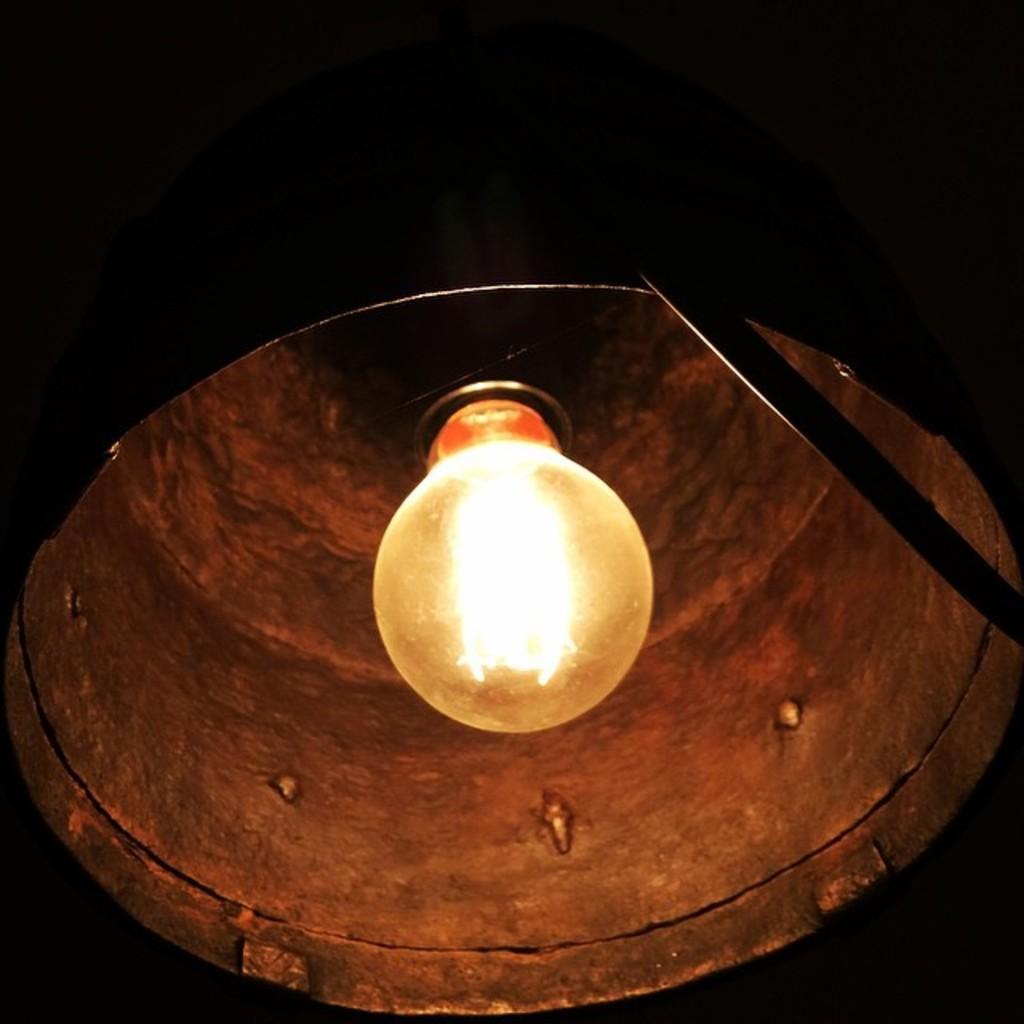How would you summarize this image in a sentence or two? In this image we can see a lamp. There is a dark background in the image. 